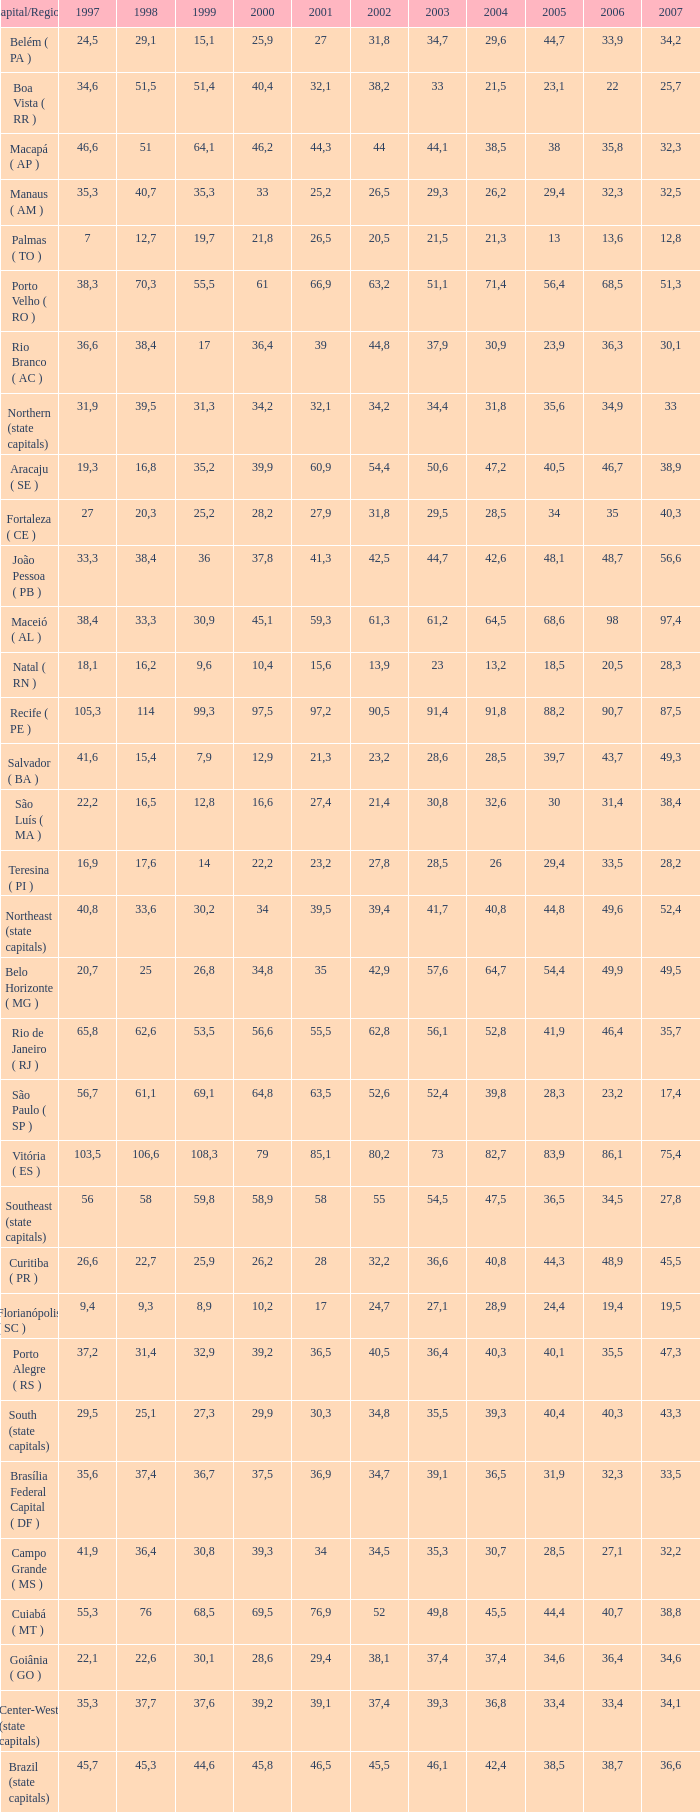What is the count of 2007's with a 2003 under 36.4, a 2001 at 27.9, and a 1999 lesser None. 